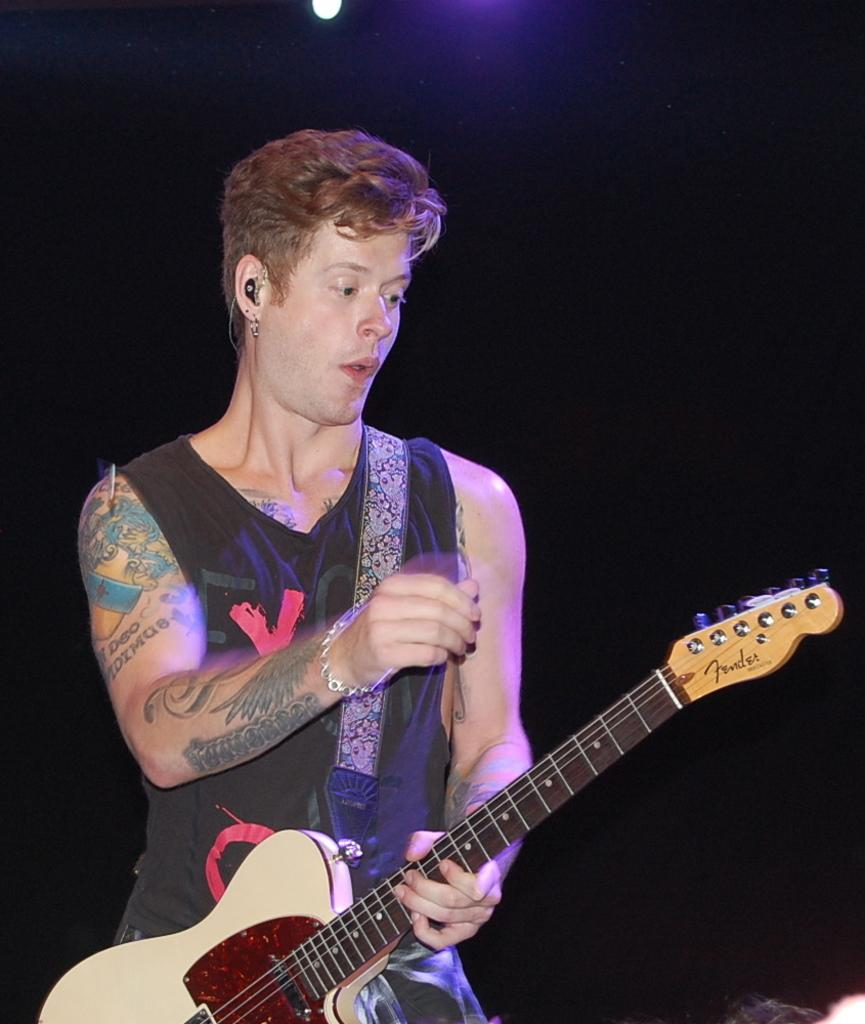What is the main subject of the image? There is a man in the image. What is the man holding in the image? The man is holding a guitar. What type of gun is the man holding in the image? There is no gun present in the image; the man is holding a guitar. What shape is the grip of the guitar in the image? The provided facts do not mention the shape of the guitar's grip, so it cannot be determined from the image. 